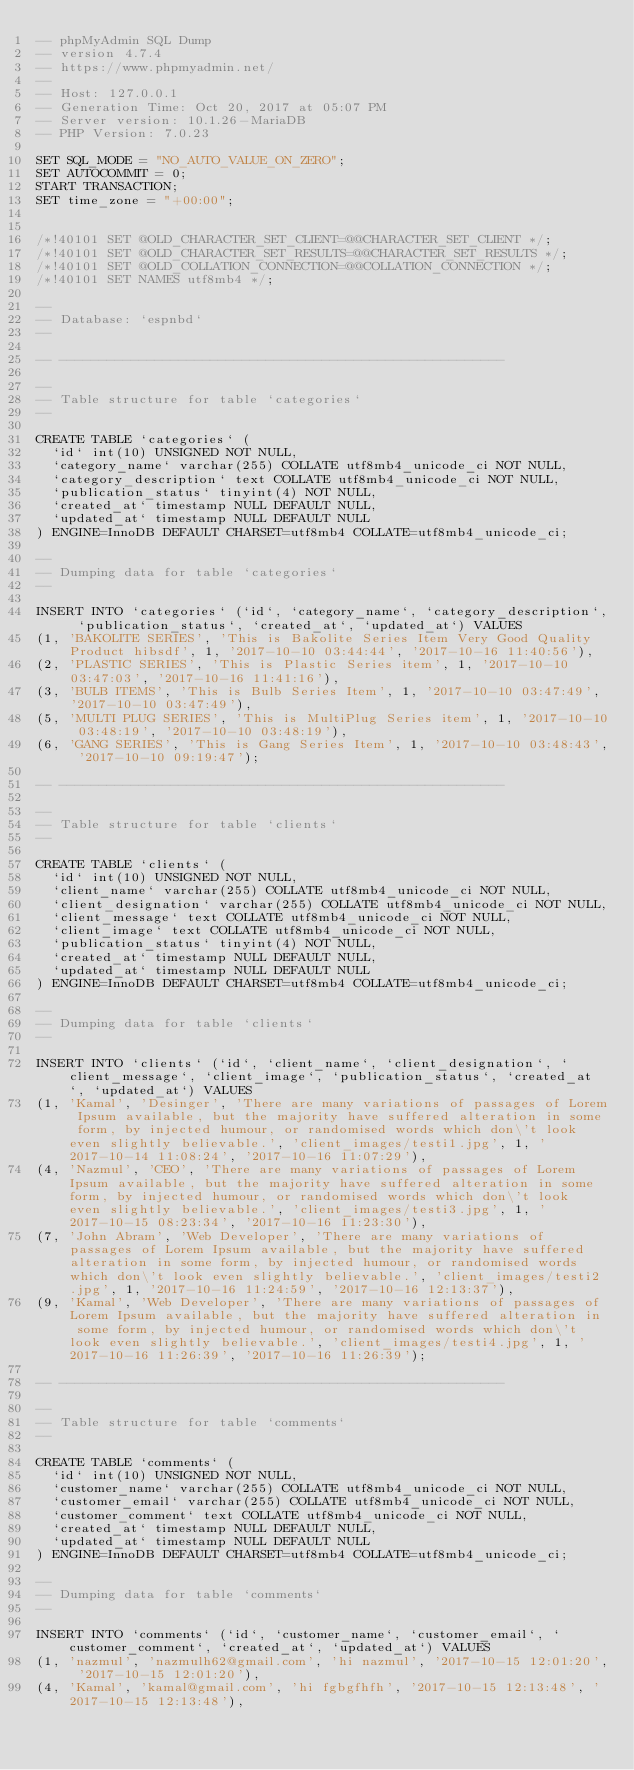Convert code to text. <code><loc_0><loc_0><loc_500><loc_500><_SQL_>-- phpMyAdmin SQL Dump
-- version 4.7.4
-- https://www.phpmyadmin.net/
--
-- Host: 127.0.0.1
-- Generation Time: Oct 20, 2017 at 05:07 PM
-- Server version: 10.1.26-MariaDB
-- PHP Version: 7.0.23

SET SQL_MODE = "NO_AUTO_VALUE_ON_ZERO";
SET AUTOCOMMIT = 0;
START TRANSACTION;
SET time_zone = "+00:00";


/*!40101 SET @OLD_CHARACTER_SET_CLIENT=@@CHARACTER_SET_CLIENT */;
/*!40101 SET @OLD_CHARACTER_SET_RESULTS=@@CHARACTER_SET_RESULTS */;
/*!40101 SET @OLD_COLLATION_CONNECTION=@@COLLATION_CONNECTION */;
/*!40101 SET NAMES utf8mb4 */;

--
-- Database: `espnbd`
--

-- --------------------------------------------------------

--
-- Table structure for table `categories`
--

CREATE TABLE `categories` (
  `id` int(10) UNSIGNED NOT NULL,
  `category_name` varchar(255) COLLATE utf8mb4_unicode_ci NOT NULL,
  `category_description` text COLLATE utf8mb4_unicode_ci NOT NULL,
  `publication_status` tinyint(4) NOT NULL,
  `created_at` timestamp NULL DEFAULT NULL,
  `updated_at` timestamp NULL DEFAULT NULL
) ENGINE=InnoDB DEFAULT CHARSET=utf8mb4 COLLATE=utf8mb4_unicode_ci;

--
-- Dumping data for table `categories`
--

INSERT INTO `categories` (`id`, `category_name`, `category_description`, `publication_status`, `created_at`, `updated_at`) VALUES
(1, 'BAKOLITE SERIES', 'This is Bakolite Series Item Very Good Quality Product hibsdf', 1, '2017-10-10 03:44:44', '2017-10-16 11:40:56'),
(2, 'PLASTIC SERIES', 'This is Plastic Series item', 1, '2017-10-10 03:47:03', '2017-10-16 11:41:16'),
(3, 'BULB ITEMS', 'This is Bulb Series Item', 1, '2017-10-10 03:47:49', '2017-10-10 03:47:49'),
(5, 'MULTI PLUG SERIES', 'This is MultiPlug Series item', 1, '2017-10-10 03:48:19', '2017-10-10 03:48:19'),
(6, 'GANG SERIES', 'This is Gang Series Item', 1, '2017-10-10 03:48:43', '2017-10-10 09:19:47');

-- --------------------------------------------------------

--
-- Table structure for table `clients`
--

CREATE TABLE `clients` (
  `id` int(10) UNSIGNED NOT NULL,
  `client_name` varchar(255) COLLATE utf8mb4_unicode_ci NOT NULL,
  `client_designation` varchar(255) COLLATE utf8mb4_unicode_ci NOT NULL,
  `client_message` text COLLATE utf8mb4_unicode_ci NOT NULL,
  `client_image` text COLLATE utf8mb4_unicode_ci NOT NULL,
  `publication_status` tinyint(4) NOT NULL,
  `created_at` timestamp NULL DEFAULT NULL,
  `updated_at` timestamp NULL DEFAULT NULL
) ENGINE=InnoDB DEFAULT CHARSET=utf8mb4 COLLATE=utf8mb4_unicode_ci;

--
-- Dumping data for table `clients`
--

INSERT INTO `clients` (`id`, `client_name`, `client_designation`, `client_message`, `client_image`, `publication_status`, `created_at`, `updated_at`) VALUES
(1, 'Kamal', 'Desinger', 'There are many variations of passages of Lorem Ipsum available, but the majority have suffered alteration in some form, by injected humour, or randomised words which don\'t look even slightly believable.', 'client_images/testi1.jpg', 1, '2017-10-14 11:08:24', '2017-10-16 11:07:29'),
(4, 'Nazmul', 'CEO', 'There are many variations of passages of Lorem Ipsum available, but the majority have suffered alteration in some form, by injected humour, or randomised words which don\'t look even slightly believable.', 'client_images/testi3.jpg', 1, '2017-10-15 08:23:34', '2017-10-16 11:23:30'),
(7, 'John Abram', 'Web Developer', 'There are many variations of passages of Lorem Ipsum available, but the majority have suffered alteration in some form, by injected humour, or randomised words which don\'t look even slightly believable.', 'client_images/testi2.jpg', 1, '2017-10-16 11:24:59', '2017-10-16 12:13:37'),
(9, 'Kamal', 'Web Developer', 'There are many variations of passages of Lorem Ipsum available, but the majority have suffered alteration in some form, by injected humour, or randomised words which don\'t look even slightly believable.', 'client_images/testi4.jpg', 1, '2017-10-16 11:26:39', '2017-10-16 11:26:39');

-- --------------------------------------------------------

--
-- Table structure for table `comments`
--

CREATE TABLE `comments` (
  `id` int(10) UNSIGNED NOT NULL,
  `customer_name` varchar(255) COLLATE utf8mb4_unicode_ci NOT NULL,
  `customer_email` varchar(255) COLLATE utf8mb4_unicode_ci NOT NULL,
  `customer_comment` text COLLATE utf8mb4_unicode_ci NOT NULL,
  `created_at` timestamp NULL DEFAULT NULL,
  `updated_at` timestamp NULL DEFAULT NULL
) ENGINE=InnoDB DEFAULT CHARSET=utf8mb4 COLLATE=utf8mb4_unicode_ci;

--
-- Dumping data for table `comments`
--

INSERT INTO `comments` (`id`, `customer_name`, `customer_email`, `customer_comment`, `created_at`, `updated_at`) VALUES
(1, 'nazmul', 'nazmulh62@gmail.com', 'hi nazmul', '2017-10-15 12:01:20', '2017-10-15 12:01:20'),
(4, 'Kamal', 'kamal@gmail.com', 'hi fgbgfhfh', '2017-10-15 12:13:48', '2017-10-15 12:13:48'),</code> 